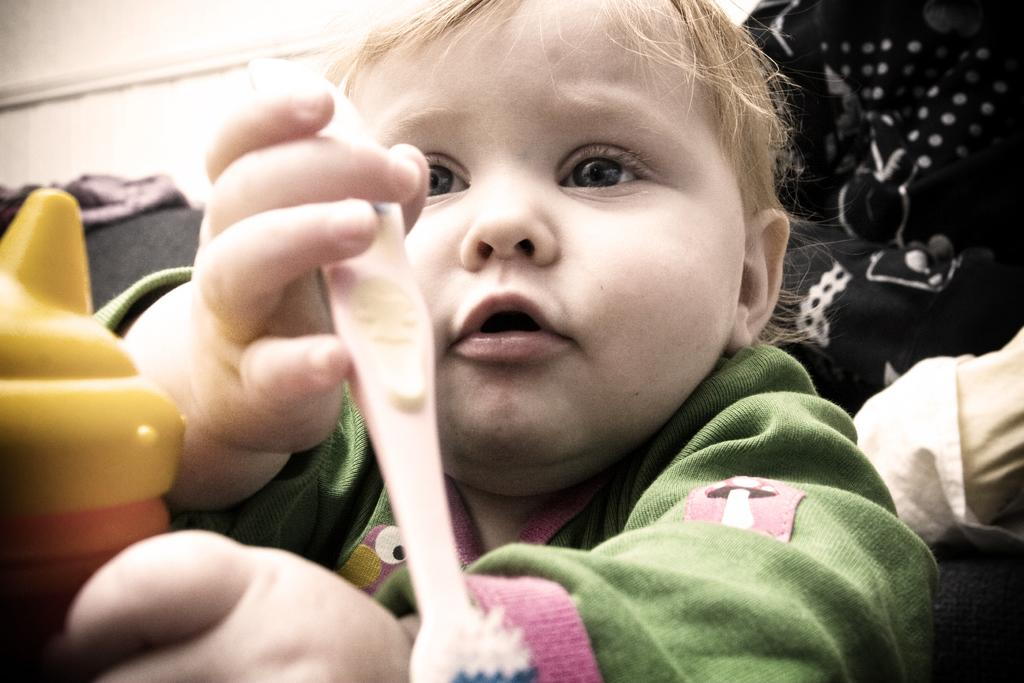What is the main subject of the image? There is a baby in the image. What is the baby doing in the image? The baby is playing with a brush. What is the baby wearing in the image? The baby is wearing a green color sweater. Can you see any trees in the image where the baby is playing? There are no trees visible in the image; it only shows a baby playing with a brush and wearing a green color sweater. 